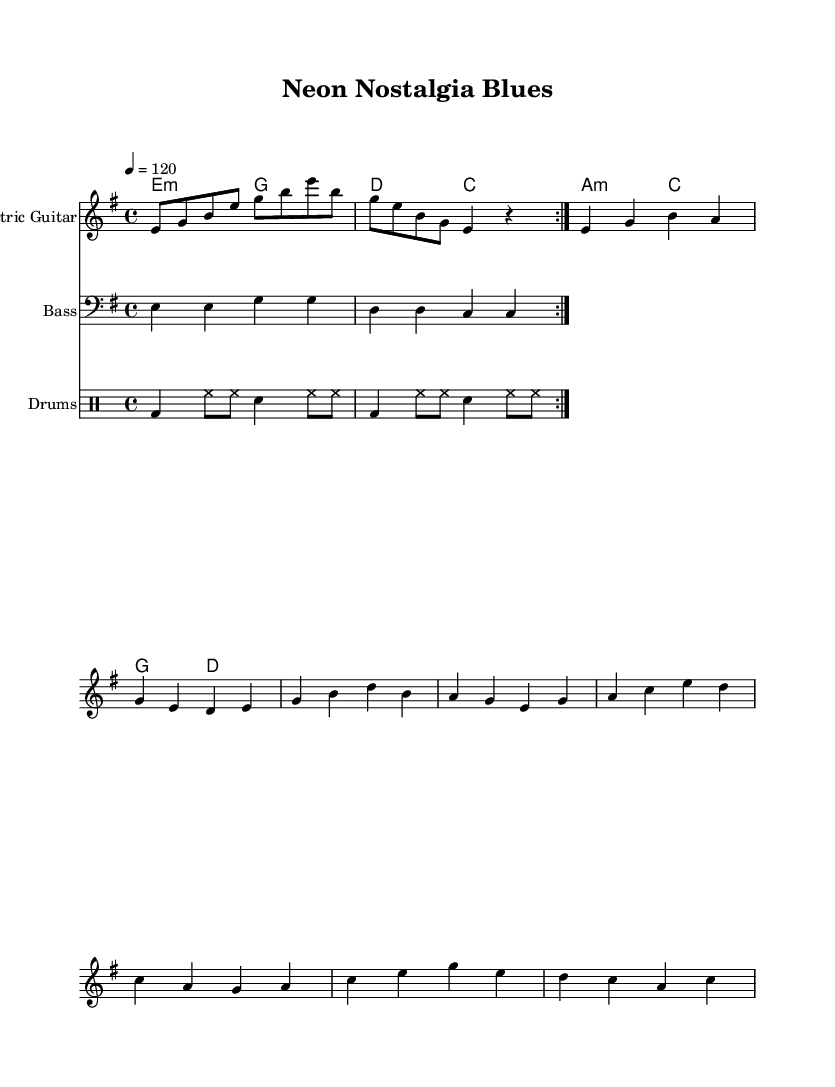What is the key signature of this music? The key signature is indicated by the key of E minor, which contains one sharp, F#.
Answer: E minor What is the time signature of the piece? The time signature is indicated at the beginning of the score, which shows 4 beats per measure.
Answer: 4/4 What is the tempo marking for the music? The tempo marking is shown next to the tempo indication, which states "4 = 120," meaning 120 beats per minute.
Answer: 120 How many measures does the intro consist of? The intro section is indicated by the repeat signs and consists of two measures repeated twice, so a total of 4 measures.
Answer: 4 What chord appears at the beginning of the verse? The first chord in the verse is indicated on the chord line and is E minor.
Answer: E minor Compare the bass line in the verse with the chorus; what is the difference in note counts? The verse contains 4 quarter notes repeated twice, totaling 8 beats, while the chorus has 8 quarter notes total. The verse is simpler and has a different rhythm.
Answer: 4 more notes in the chorus What genre influences the overall style of this piece? The sheet music's title references "Neon Nostalgia Blues," implying a blend of electric blues rock, influenced by 80s and 90s anime soundtracks.
Answer: Electric blues rock 